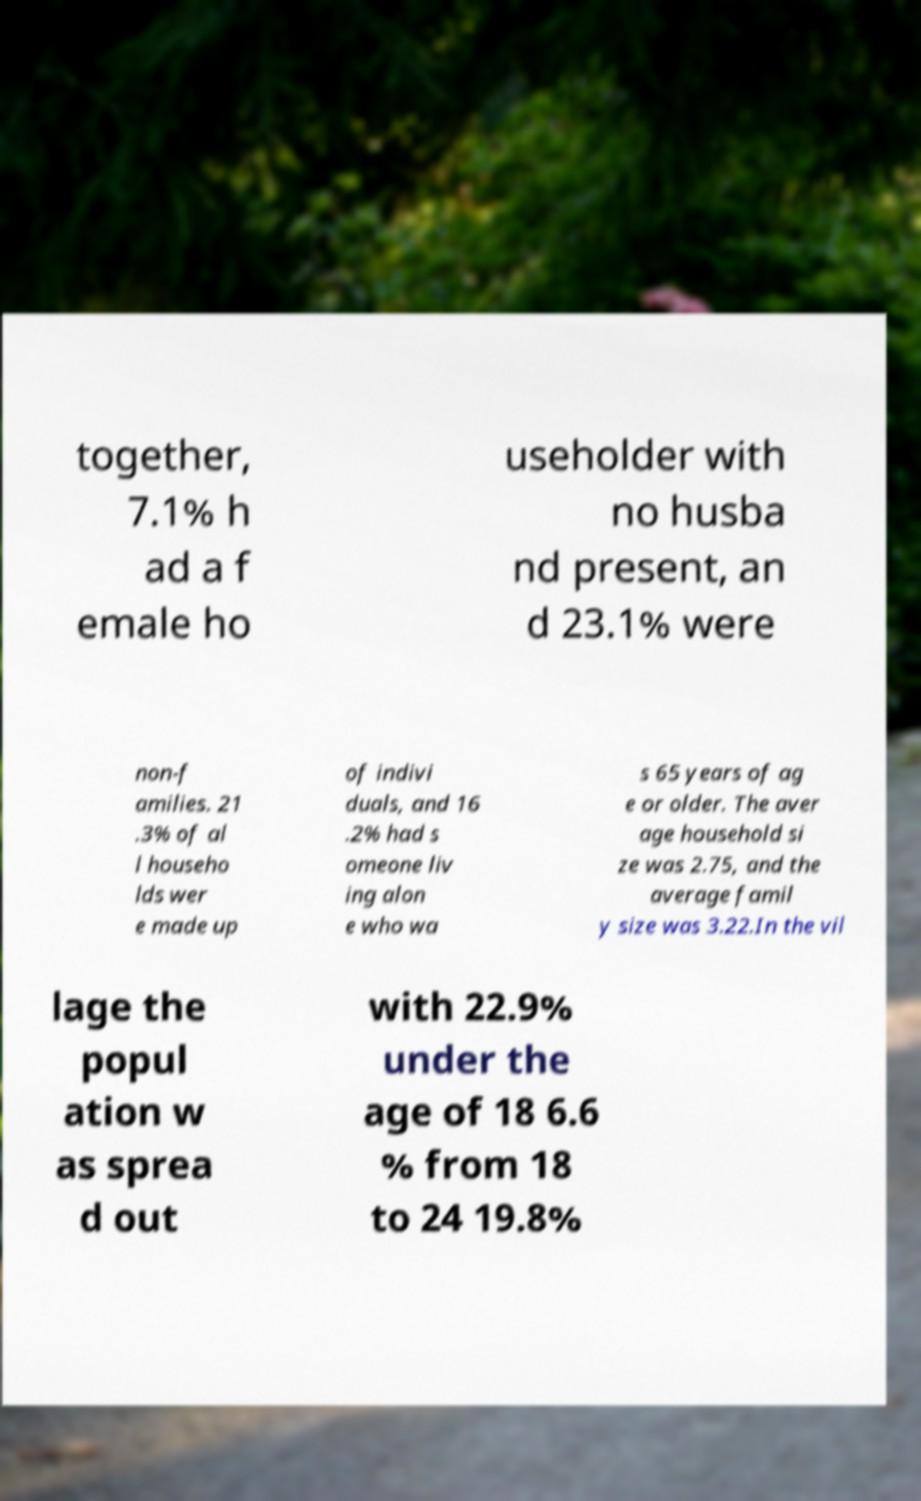Could you extract and type out the text from this image? together, 7.1% h ad a f emale ho useholder with no husba nd present, an d 23.1% were non-f amilies. 21 .3% of al l househo lds wer e made up of indivi duals, and 16 .2% had s omeone liv ing alon e who wa s 65 years of ag e or older. The aver age household si ze was 2.75, and the average famil y size was 3.22.In the vil lage the popul ation w as sprea d out with 22.9% under the age of 18 6.6 % from 18 to 24 19.8% 